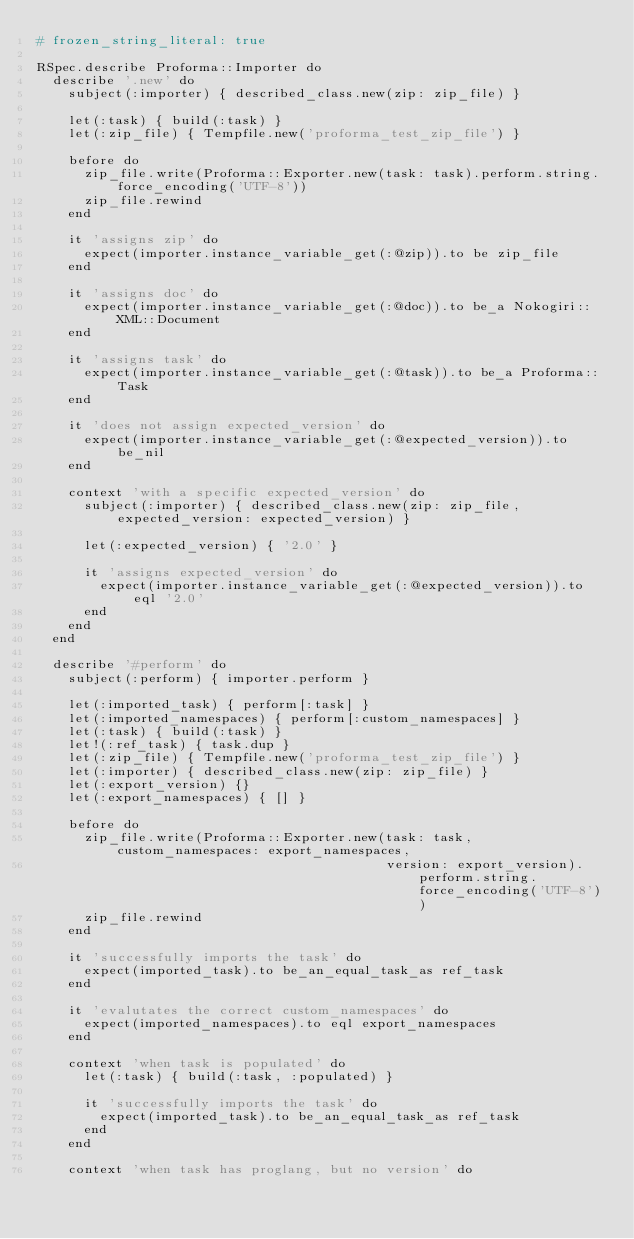Convert code to text. <code><loc_0><loc_0><loc_500><loc_500><_Ruby_># frozen_string_literal: true

RSpec.describe Proforma::Importer do
  describe '.new' do
    subject(:importer) { described_class.new(zip: zip_file) }

    let(:task) { build(:task) }
    let(:zip_file) { Tempfile.new('proforma_test_zip_file') }

    before do
      zip_file.write(Proforma::Exporter.new(task: task).perform.string.force_encoding('UTF-8'))
      zip_file.rewind
    end

    it 'assigns zip' do
      expect(importer.instance_variable_get(:@zip)).to be zip_file
    end

    it 'assigns doc' do
      expect(importer.instance_variable_get(:@doc)).to be_a Nokogiri::XML::Document
    end

    it 'assigns task' do
      expect(importer.instance_variable_get(:@task)).to be_a Proforma::Task
    end

    it 'does not assign expected_version' do
      expect(importer.instance_variable_get(:@expected_version)).to be_nil
    end

    context 'with a specific expected_version' do
      subject(:importer) { described_class.new(zip: zip_file, expected_version: expected_version) }

      let(:expected_version) { '2.0' }

      it 'assigns expected_version' do
        expect(importer.instance_variable_get(:@expected_version)).to eql '2.0'
      end
    end
  end

  describe '#perform' do
    subject(:perform) { importer.perform }

    let(:imported_task) { perform[:task] }
    let(:imported_namespaces) { perform[:custom_namespaces] }
    let(:task) { build(:task) }
    let!(:ref_task) { task.dup }
    let(:zip_file) { Tempfile.new('proforma_test_zip_file') }
    let(:importer) { described_class.new(zip: zip_file) }
    let(:export_version) {}
    let(:export_namespaces) { [] }

    before do
      zip_file.write(Proforma::Exporter.new(task: task, custom_namespaces: export_namespaces,
                                            version: export_version).perform.string.force_encoding('UTF-8'))
      zip_file.rewind
    end

    it 'successfully imports the task' do
      expect(imported_task).to be_an_equal_task_as ref_task
    end

    it 'evalutates the correct custom_namespaces' do
      expect(imported_namespaces).to eql export_namespaces
    end

    context 'when task is populated' do
      let(:task) { build(:task, :populated) }

      it 'successfully imports the task' do
        expect(imported_task).to be_an_equal_task_as ref_task
      end
    end

    context 'when task has proglang, but no version' do</code> 